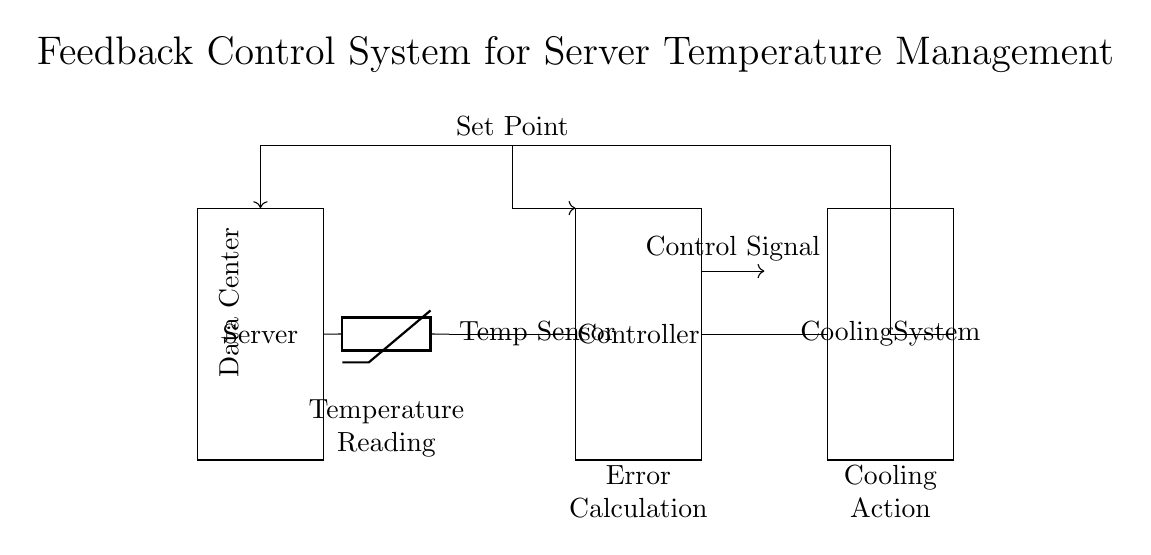What is the main component that senses temperature? The temperature sensor, represented as a thermistor, is the main component that detects the temperature of the server.
Answer: Temperature sensor What action does the cooling system perform? The cooling system's role is to reduce the temperature within the data center, acting based on the control signal generated from the error calculation.
Answer: Cooling What is the purpose of the controller in this circuit? The controller processes the temperature reading from the temperature sensor, compares it to the set point, and generates a control signal for the cooling system.
Answer: Manage temperature What does the feedback loop signify in this system? The feedback loop indicates that the output (cooling action) is fed back into the system to adjust the input (temperature reading), ensuring stable temperature control.
Answer: Error correction At which point is the set point applied in the circuit? The set point is applied at the controller, where it is compared to the current temperature reading to compute the error signal.
Answer: Controller What would happen if the temperature exceeds the set point? If the temperature exceeds the set point, the controller computes a positive error signal, prompting the cooling system to activate and lower the temperature.
Answer: Cooling Action 